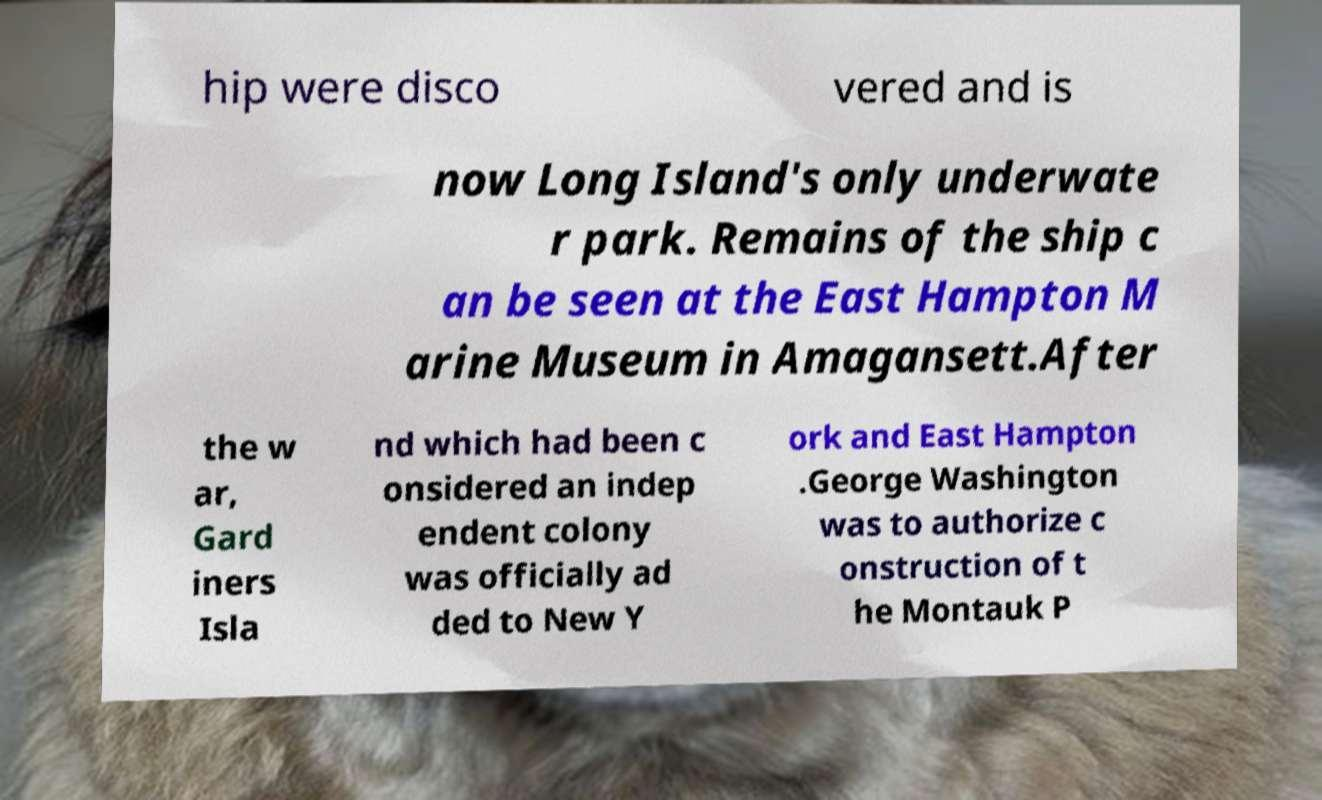Please identify and transcribe the text found in this image. hip were disco vered and is now Long Island's only underwate r park. Remains of the ship c an be seen at the East Hampton M arine Museum in Amagansett.After the w ar, Gard iners Isla nd which had been c onsidered an indep endent colony was officially ad ded to New Y ork and East Hampton .George Washington was to authorize c onstruction of t he Montauk P 